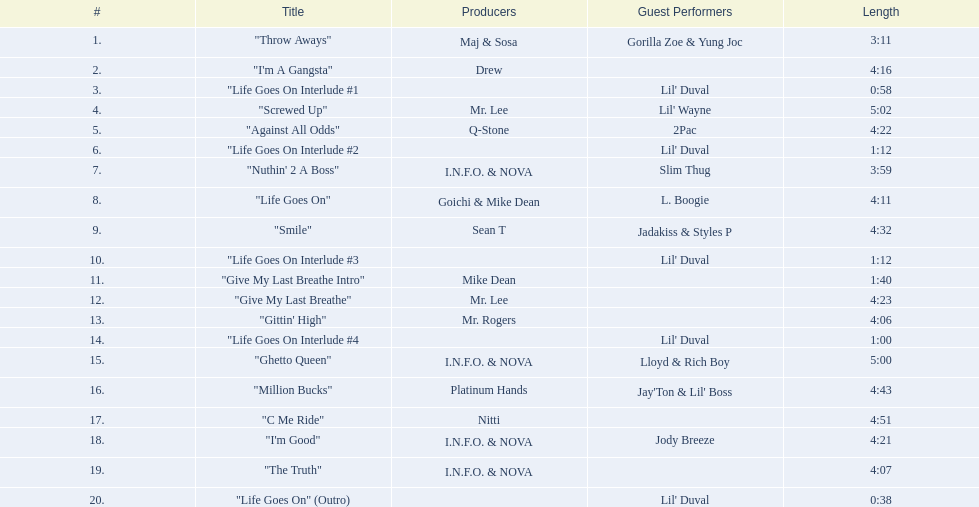What tunes can be found on the album life goes on (trae album)? "Throw Aways", "I'm A Gangsta", "Life Goes On Interlude #1, "Screwed Up", "Against All Odds", "Life Goes On Interlude #2, "Nuthin' 2 A Boss", "Life Goes On", "Smile", "Life Goes On Interlude #3, "Give My Last Breathe Intro", "Give My Last Breathe", "Gittin' High", "Life Goes On Interlude #4, "Ghetto Queen", "Million Bucks", "C Me Ride", "I'm Good", "The Truth", "Life Goes On" (Outro). Which of these melodies last for a minimum of 5 minutes? "Screwed Up", "Ghetto Queen". Out of these two songs with over 5 minutes duration, which one is lengthier? "Screwed Up". How long does this specific track last? 5:02. 